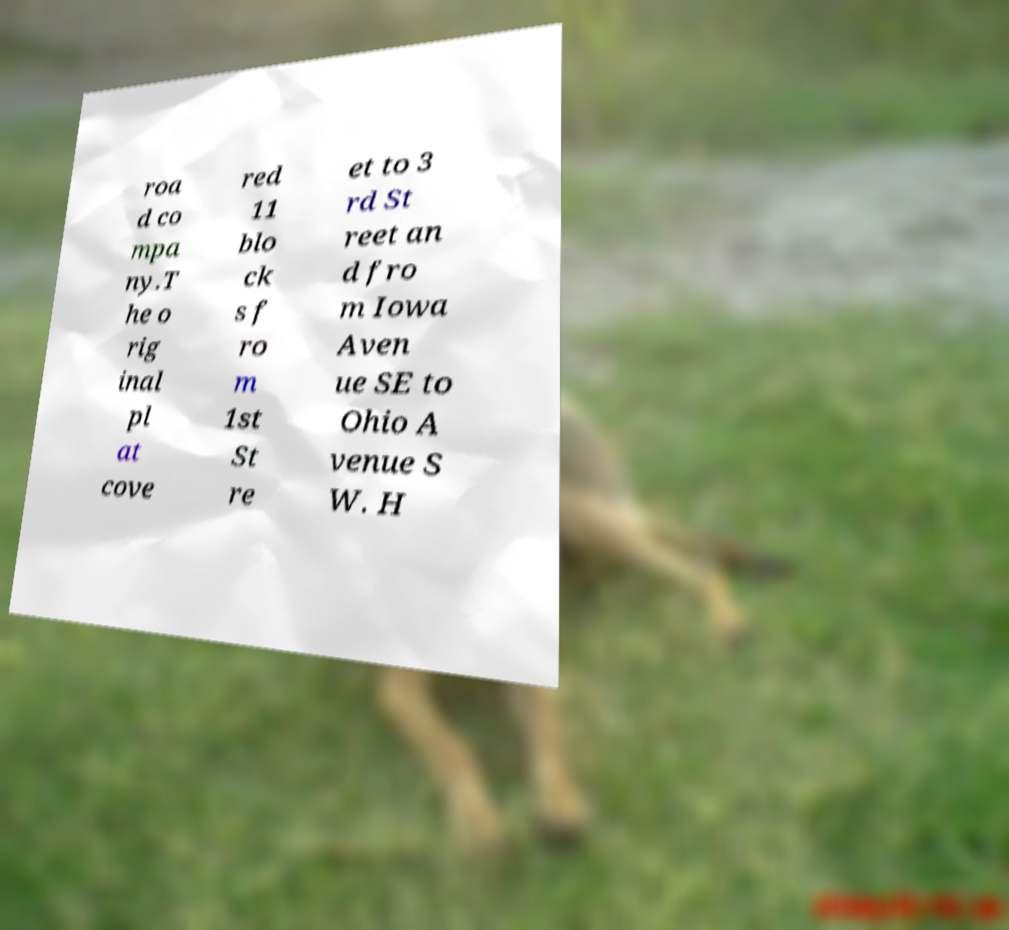There's text embedded in this image that I need extracted. Can you transcribe it verbatim? roa d co mpa ny.T he o rig inal pl at cove red 11 blo ck s f ro m 1st St re et to 3 rd St reet an d fro m Iowa Aven ue SE to Ohio A venue S W. H 